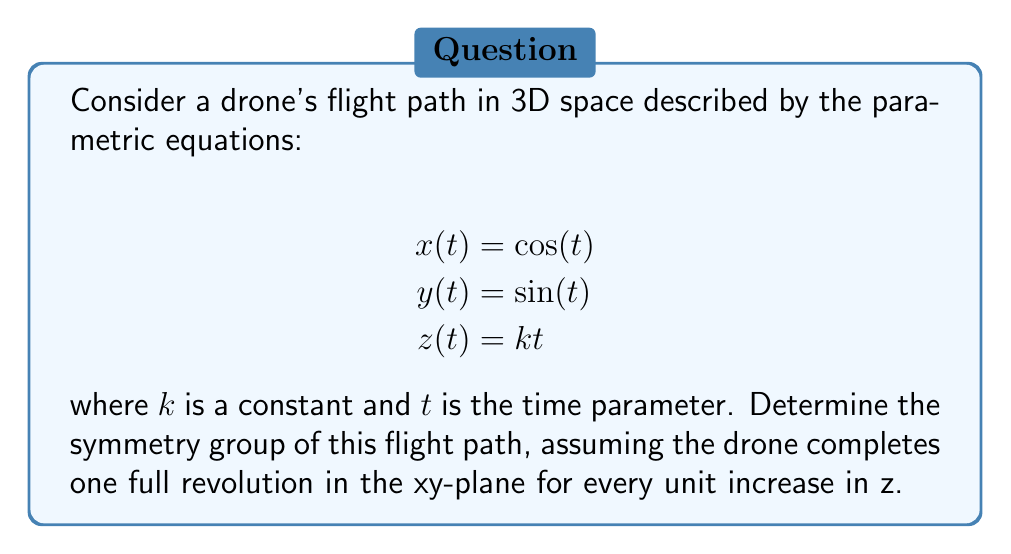Can you solve this math problem? Let's approach this step-by-step:

1) First, we need to visualize the flight path. It forms a helical trajectory in 3D space.

2) The symmetries we need to consider are:
   a) Rotations around the z-axis
   b) Translations along the z-axis
   c) Reflections (if any)

3) Rotations around the z-axis:
   - The path completes a full 360° rotation for every unit increase in z.
   - This means we have continuous rotational symmetry around the z-axis.

4) Translations along the z-axis:
   - The path repeats itself every time z increases by 1 unit.
   - This gives us discrete translational symmetry along the z-axis.

5) Reflections:
   - There are no reflection symmetries in this path due to its helical nature.

6) The combination of continuous rotations around the z-axis and discrete translations along the z-axis forms a group known as the helical group.

7) In mathematical notation, this group can be described as:

   $$G = \{(R_\theta, T_n) | \theta \in [0, 2\pi), n \in \mathbb{Z}\}$$

   where $R_\theta$ represents a rotation by angle $\theta$ around the z-axis, and $T_n$ represents a translation by $n$ units along the z-axis.

8) This group is isomorphic to the direct product of the circle group $S^1$ (representing rotations) and the integer group $\mathbb{Z}$ (representing translations).
Answer: $S^1 \times \mathbb{Z}$ 